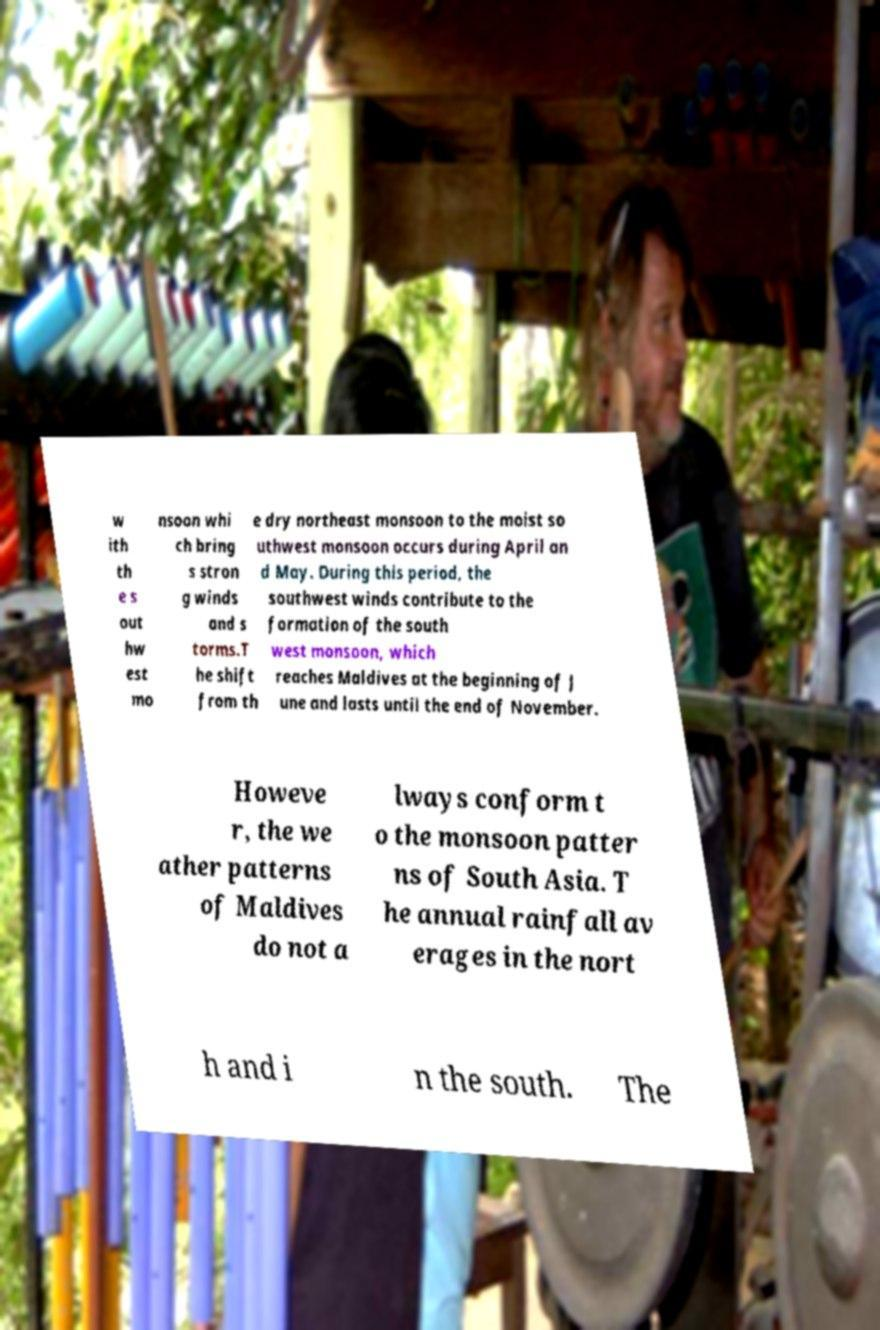Please identify and transcribe the text found in this image. w ith th e s out hw est mo nsoon whi ch bring s stron g winds and s torms.T he shift from th e dry northeast monsoon to the moist so uthwest monsoon occurs during April an d May. During this period, the southwest winds contribute to the formation of the south west monsoon, which reaches Maldives at the beginning of J une and lasts until the end of November. Howeve r, the we ather patterns of Maldives do not a lways conform t o the monsoon patter ns of South Asia. T he annual rainfall av erages in the nort h and i n the south. The 